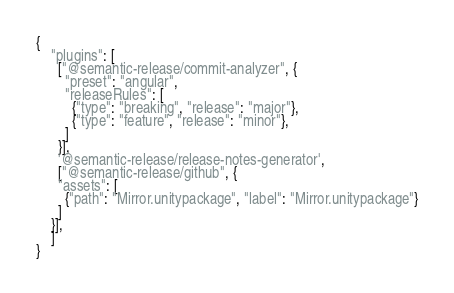<code> <loc_0><loc_0><loc_500><loc_500><_YAML_>{
    "plugins": [
      ["@semantic-release/commit-analyzer", {
        "preset": "angular",
        "releaseRules": [
          {"type": "breaking", "release": "major"},
          {"type": "feature", "release": "minor"},
        ]
      }],
      '@semantic-release/release-notes-generator', 
      ["@semantic-release/github", {
      "assets": [
        {"path": "Mirror.unitypackage", "label": "Mirror.unitypackage"}
      ]
    }],
    ]
}
</code> 